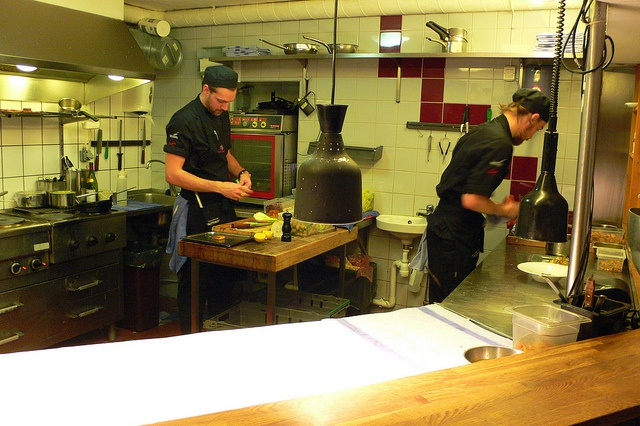Describe the objects in this image and their specific colors. I can see people in olive, black, brown, and maroon tones, people in olive, black, brown, gray, and red tones, dining table in olive, black, and maroon tones, oven in olive, black, and maroon tones, and oven in olive, black, and darkgreen tones in this image. 